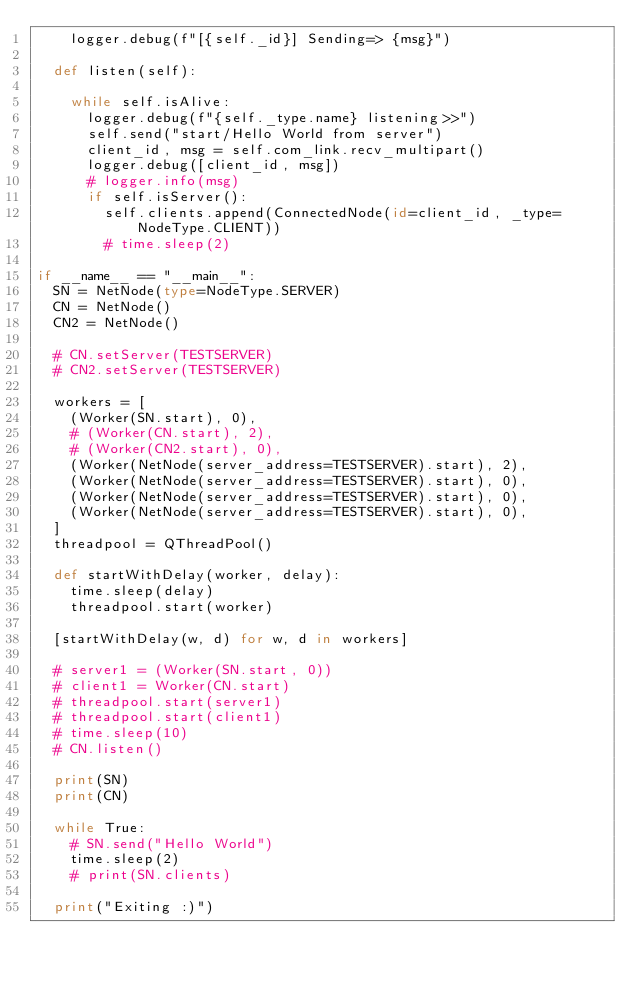<code> <loc_0><loc_0><loc_500><loc_500><_Python_>		logger.debug(f"[{self._id}] Sending=> {msg}")

	def listen(self):

		while self.isAlive:
			logger.debug(f"{self._type.name} listening>>")
			self.send("start/Hello World from server")
			client_id, msg = self.com_link.recv_multipart()
			logger.debug([client_id, msg])
			# logger.info(msg)
			if self.isServer():
				self.clients.append(ConnectedNode(id=client_id, _type=NodeType.CLIENT))
				# time.sleep(2)

if __name__ == "__main__":
	SN = NetNode(type=NodeType.SERVER)
	CN = NetNode()
	CN2 = NetNode()

	# CN.setServer(TESTSERVER)
	# CN2.setServer(TESTSERVER)

	workers = [
		(Worker(SN.start), 0),
		# (Worker(CN.start), 2),
		# (Worker(CN2.start), 0),
		(Worker(NetNode(server_address=TESTSERVER).start), 2),
		(Worker(NetNode(server_address=TESTSERVER).start), 0),
		(Worker(NetNode(server_address=TESTSERVER).start), 0),
		(Worker(NetNode(server_address=TESTSERVER).start), 0),
	]
	threadpool = QThreadPool()

	def startWithDelay(worker, delay):
		time.sleep(delay)
		threadpool.start(worker)

	[startWithDelay(w, d) for w, d in workers]
	
	# server1 = (Worker(SN.start, 0))
	# client1 = Worker(CN.start)
	# threadpool.start(server1)
	# threadpool.start(client1)	
	# time.sleep(10)
	# CN.listen()

	print(SN)
	print(CN)

	while True:
		# SN.send("Hello World")
		time.sleep(2)
		# print(SN.clients)

	print("Exiting :)")</code> 